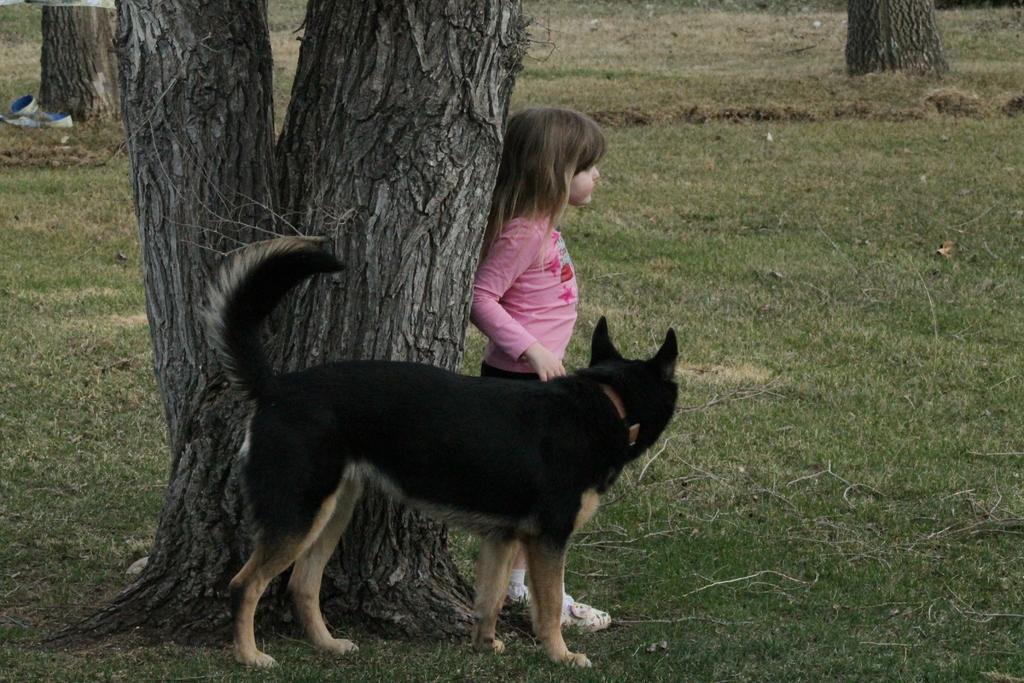Can you describe this image briefly? This girl is standing beside this tree with a dog. Grass is in green color. 